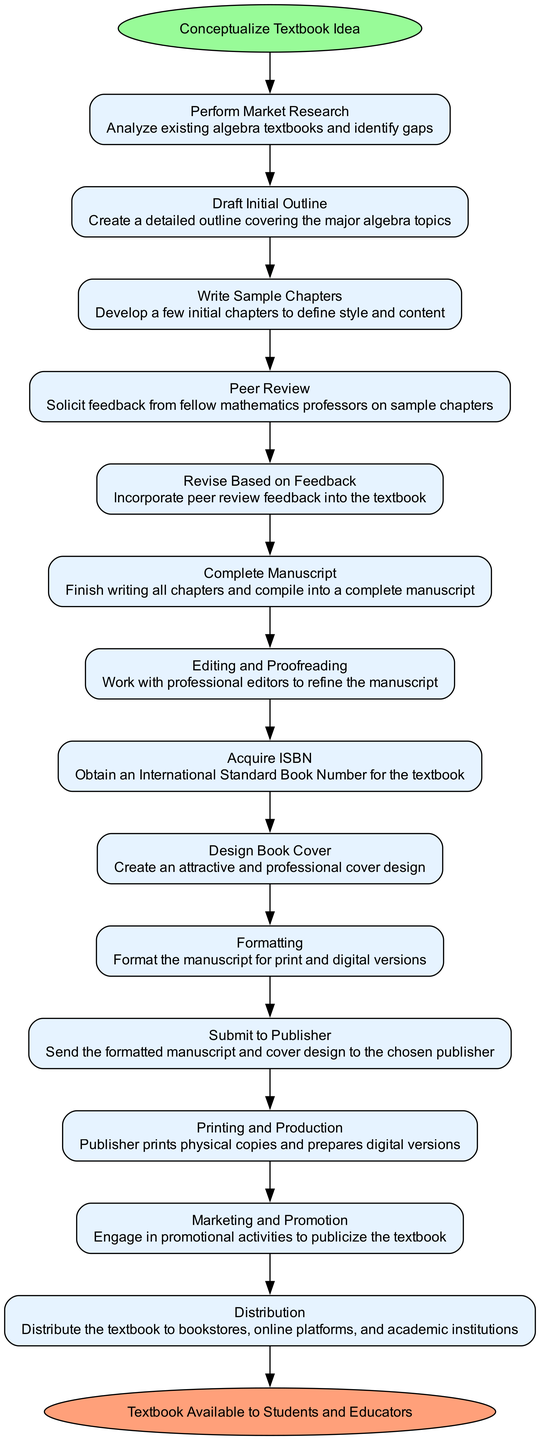What is the first activity in the diagram? The diagram starts with the first activity labeled "Perform Market Research." Since it is the first listed activity after the starting node, it directly follows the initial concept.
Answer: Perform Market Research How many activities are listed in the diagram? There are a total of 14 activities listed in the diagram, including the start and end nodes. By counting all the activities from the beginning to the end, we find this total.
Answer: 14 What is the last activity before the end node? The last activity before reaching the end node is "Distribution." By following the path through the activities, it is the final step that leads directly to the end.
Answer: Distribution Which activity involves feedback from fellow professors? The activity labeled "Peer Review" involves soliciting feedback from fellow mathematics professors on the sample chapters. This can be identified by looking for activities that mention feedback.
Answer: Peer Review What is the relationship between "Revise Based on Feedback" and "Peer Review"? "Revise Based on Feedback" follows directly after "Peer Review," indicating that revisions are made after the feedback is collected from professors. This sequential flow means one activity leads to the other.
Answer: Sequential How many activities occur between "Draft Initial Outline" and "Complete Manuscript"? There are three activities between "Draft Initial Outline" and "Complete Manuscript": "Write Sample Chapters," "Peer Review," and "Revise Based on Feedback." Counting these in-between activities gives the answer.
Answer: 3 What does the activity "Acquire ISBN" represent? The activity "Acquire ISBN" represents the process of obtaining an International Standard Book Number for the textbook. It is specifically designated to ensure the textbook can be uniquely identified in publishing.
Answer: ISBN What happens after "Editing and Proofreading"? After "Editing and Proofreading," the next activity is "Acquire ISBN," indicating that obtaining the ISBN follows the editing process in the flow of developing the textbook.
Answer: Acquire ISBN Which activity involves designing an attractive cover? The activity labeled "Design Book Cover" is specifically focused on creating an attractive and professional cover design for the textbook. It is clearly stated in the activities listed.
Answer: Design Book Cover 